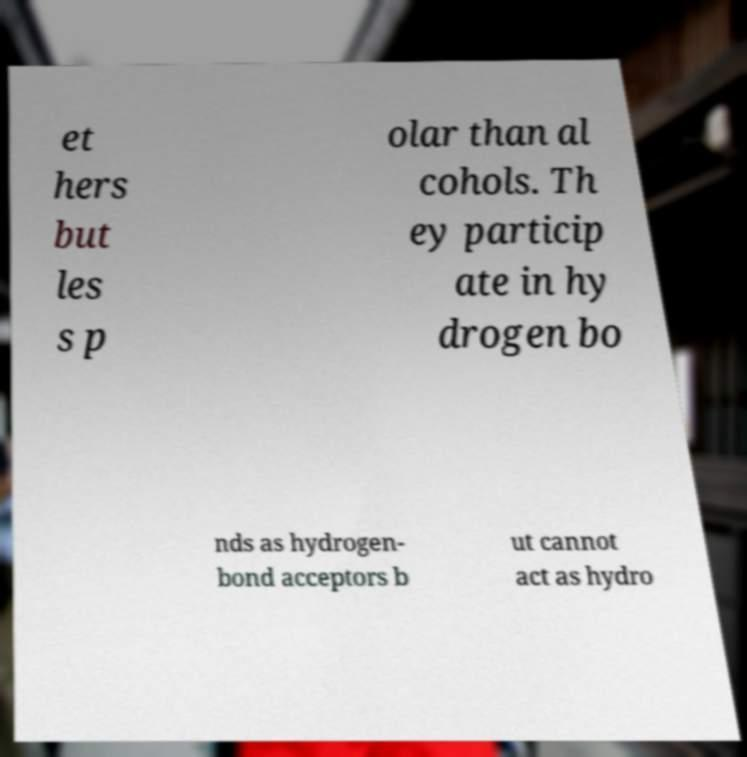Can you accurately transcribe the text from the provided image for me? et hers but les s p olar than al cohols. Th ey particip ate in hy drogen bo nds as hydrogen- bond acceptors b ut cannot act as hydro 